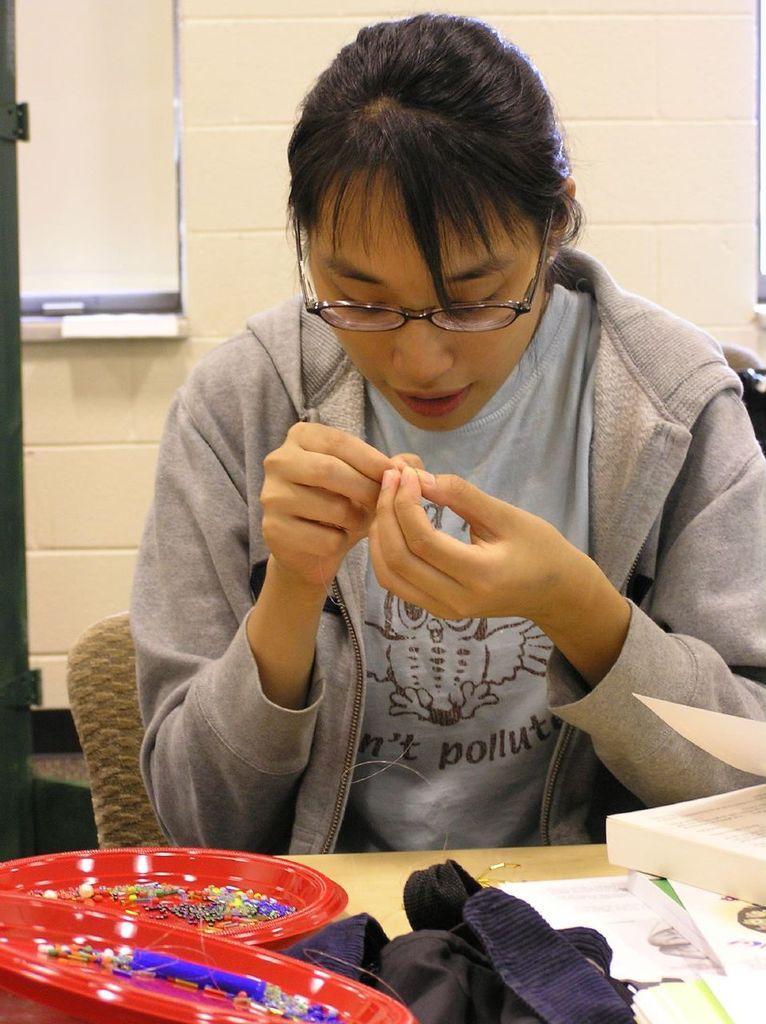Could you give a brief overview of what you see in this image? In this image, there is a woman sitting in a chair, and wearing gray jacket. This image is clicked inside a room. She is also wearing spectacles. In front of her there is a table, on which there are two red plates, a cloth and book. In the background there is a wall and window. 